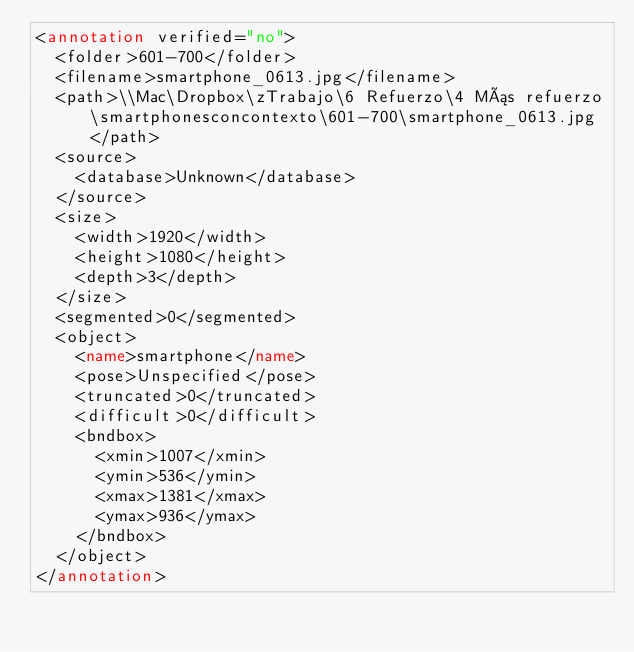<code> <loc_0><loc_0><loc_500><loc_500><_XML_><annotation verified="no">
	<folder>601-700</folder>
	<filename>smartphone_0613.jpg</filename>
	<path>\\Mac\Dropbox\zTrabajo\6 Refuerzo\4 Más refuerzo\smartphonesconcontexto\601-700\smartphone_0613.jpg</path>
	<source>
		<database>Unknown</database>
	</source>
	<size>
		<width>1920</width>
		<height>1080</height>
		<depth>3</depth>
	</size>
	<segmented>0</segmented>
	<object>
		<name>smartphone</name>
		<pose>Unspecified</pose>
		<truncated>0</truncated>
		<difficult>0</difficult>
		<bndbox>
			<xmin>1007</xmin>
			<ymin>536</ymin>
			<xmax>1381</xmax>
			<ymax>936</ymax>
		</bndbox>
	</object>
</annotation>
</code> 